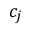<formula> <loc_0><loc_0><loc_500><loc_500>c _ { j }</formula> 